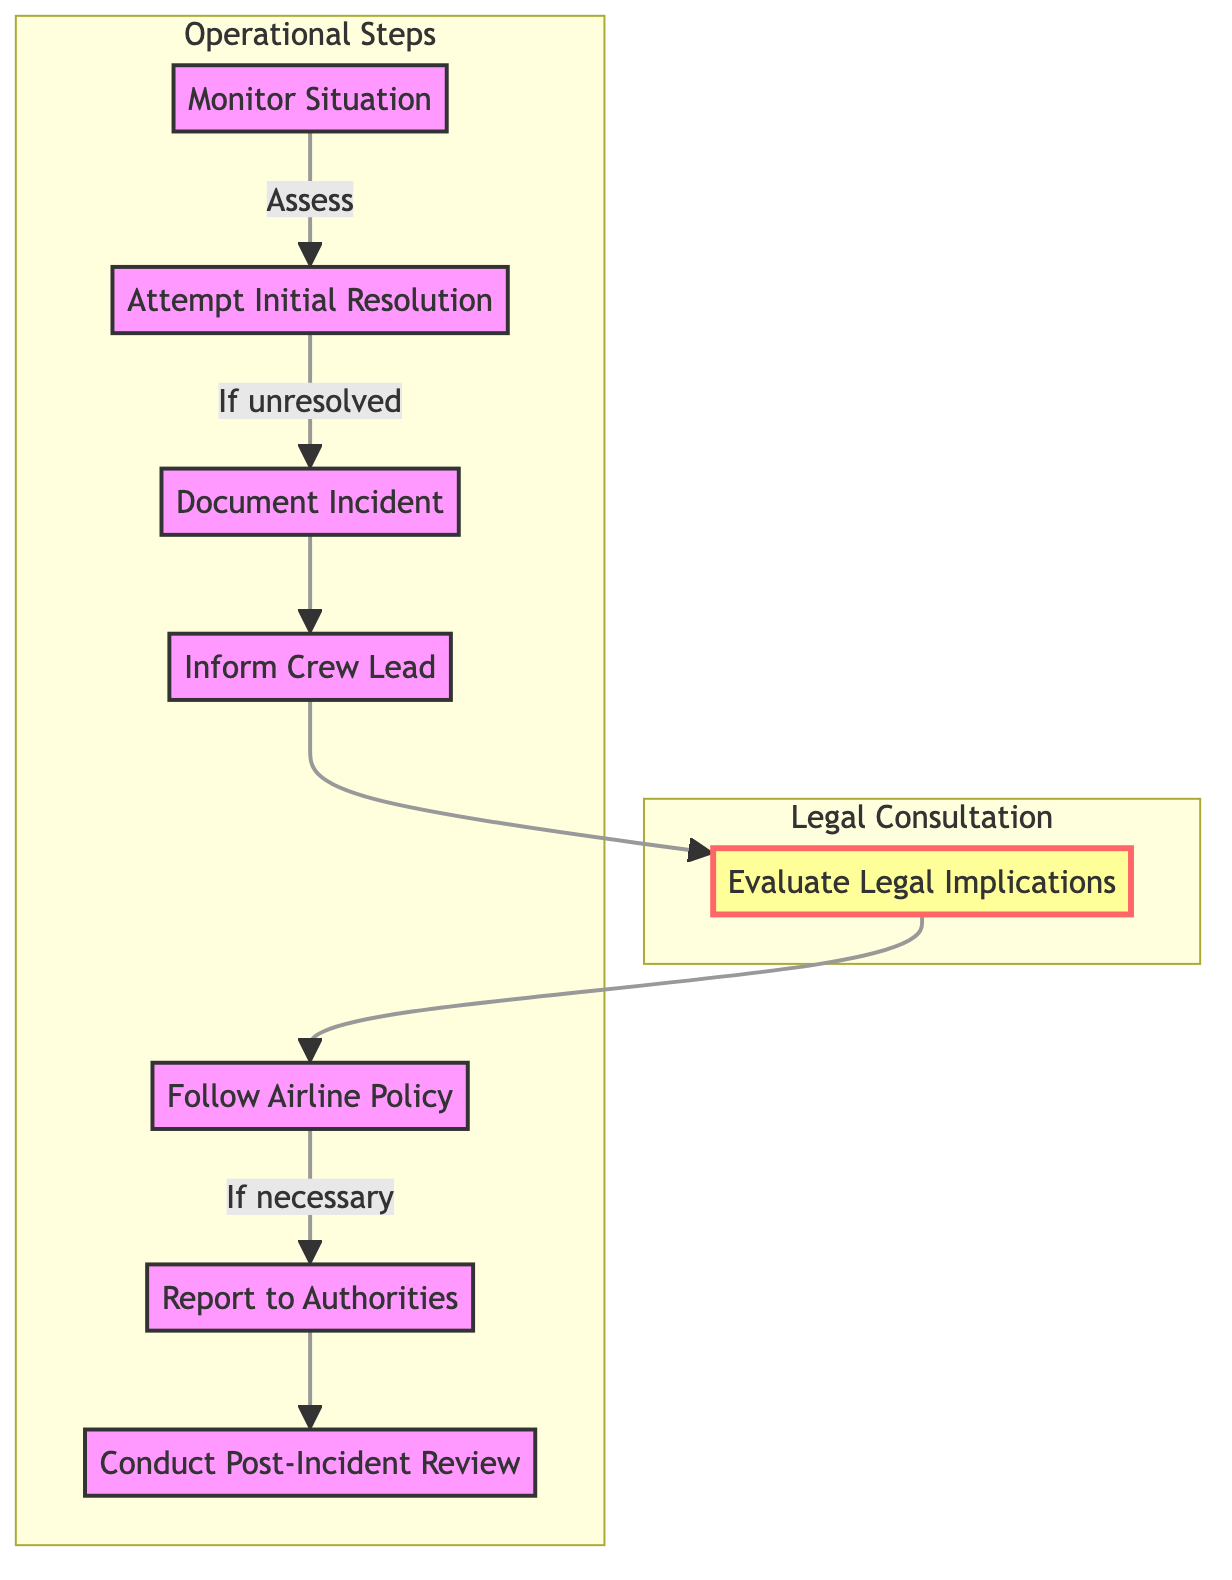What is the first step in addressing passenger disputes? The first step in the process is "Monitor Situation," which involves observing and assessing the passenger's behavior and situation. This node is the starting point of the flowchart.
Answer: Monitor Situation How many steps are there in the flowchart? By counting the distinct steps listed in the flowchart, we find eight steps that outline the process for addressing passenger disputes.
Answer: Eight What is the outcome if the initial resolution is unsuccessful? If the initial resolution is unsuccessful, the flowchart indicates that the next step is "Document Incident," which involves recording the details of the situation.
Answer: Document Incident Which step follows "Inform Crew Lead"? After "Inform Crew Lead," the next step in the sequence is "Evaluate Legal Implications," where consulting with an aviation lawyer about potential legal consequences occurs.
Answer: Evaluate Legal Implications What actions are implemented after evaluating legal implications? After evaluating legal implications, the next step is to "Follow Airline Policy," which means implementing the airline’s policies and procedures for managing passenger disputes.
Answer: Follow Airline Policy What occurs if the situation requires alerting authorities? If necessary, the flow indicates that the next step would be to "Report to Authorities," which involves determining if the situation requires informing airport security or law enforcement.
Answer: Report to Authorities How does the "Conduct Post-Incident Review" relate to the other steps? "Conduct Post-Incident Review" is the final step in the flowchart, indicating that after addressing all previous steps and any incidents that occurred, the crew should review the situation for potential procedure adjustments.
Answer: Final step What is the purpose of documenting the incident? Documenting the incident serves to record details of the situation, including time, location, and nature of the dispute, which is essential for legal considerations and future reference.
Answer: Record details Which step emphasizes legal consultation? The step that emphasizes legal consultation is "Evaluate Legal Implications," where the crew consults with an aviation lawyer regarding potential legal consequences of the incident.
Answer: Evaluate Legal Implications 